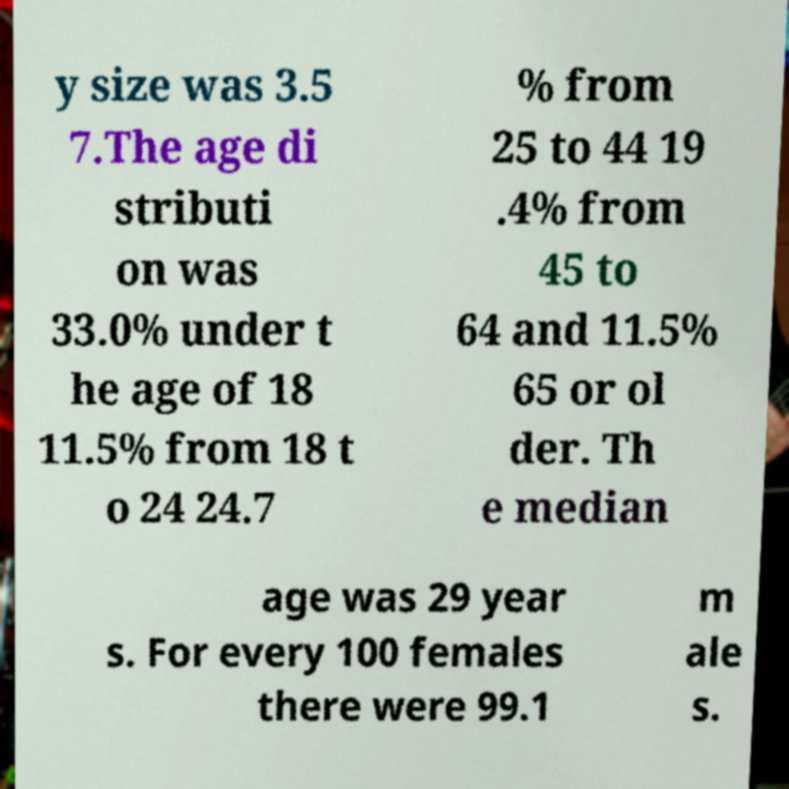For documentation purposes, I need the text within this image transcribed. Could you provide that? y size was 3.5 7.The age di stributi on was 33.0% under t he age of 18 11.5% from 18 t o 24 24.7 % from 25 to 44 19 .4% from 45 to 64 and 11.5% 65 or ol der. Th e median age was 29 year s. For every 100 females there were 99.1 m ale s. 